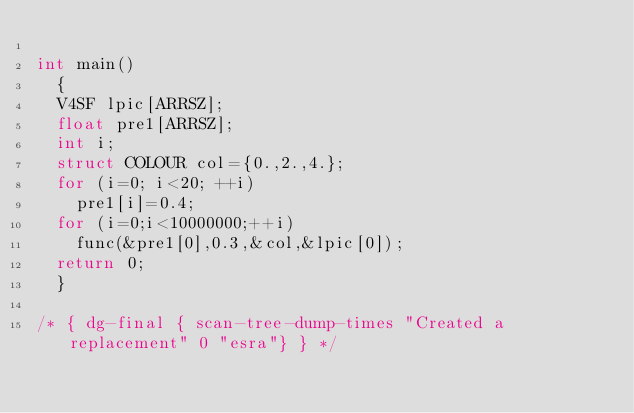<code> <loc_0><loc_0><loc_500><loc_500><_C_>
int main()
  {
  V4SF lpic[ARRSZ];
  float pre1[ARRSZ];
  int i;
  struct COLOUR col={0.,2.,4.};
  for (i=0; i<20; ++i)
    pre1[i]=0.4;
  for (i=0;i<10000000;++i)
    func(&pre1[0],0.3,&col,&lpic[0]);
  return 0;
  }

/* { dg-final { scan-tree-dump-times "Created a replacement" 0 "esra"} } */
</code> 